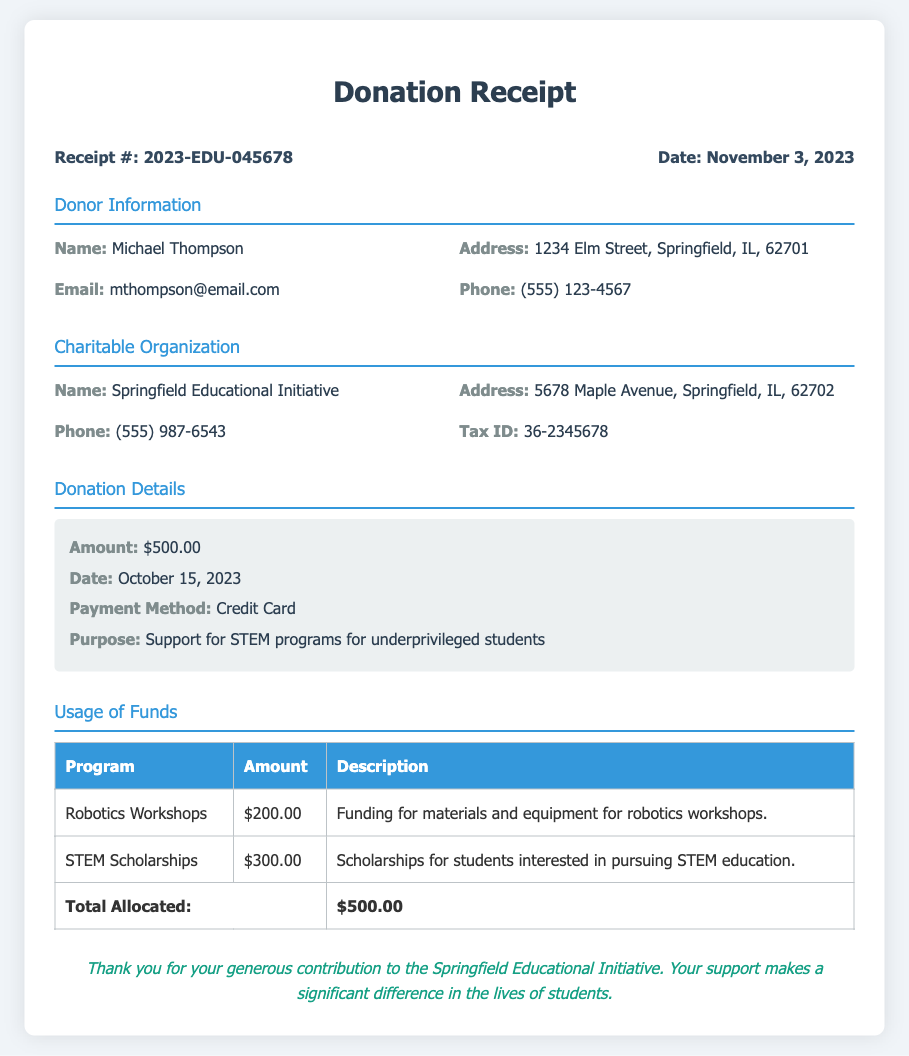what is the donor's name? The donor's name is listed under "Donor Information" as Michael Thompson.
Answer: Michael Thompson what is the donation amount? The donation amount is specified in the "Donation Details" section as $500.00.
Answer: $500.00 when was the donation made? The date of the donation is found in the "Donation Details" section as October 15, 2023.
Answer: October 15, 2023 what is the purpose of the donation? The purpose of the donation is stated in the "Donation Details" section to support STEM programs for underprivileged students.
Answer: Support for STEM programs for underprivileged students how much is allocated for Robotics Workshops? The amount allocated for Robotics Workshops is detailed in the "Usage of Funds" section as $200.00.
Answer: $200.00 who is the charitable organization? The charitable organization is mentioned in the document as Springfield Educational Initiative.
Answer: Springfield Educational Initiative what is the total allocated amount? The total allocated amount can be found in the "Usage of Funds" section and is explicitly stated as $500.00.
Answer: $500.00 what payment method was used for the donation? The payment method for the donation is indicated in the "Donation Details" section as Credit Card.
Answer: Credit Card what is the tax ID of the organization? The tax ID of the charitable organization is mentioned in the "Charitable Organization" section as 36-2345678.
Answer: 36-2345678 